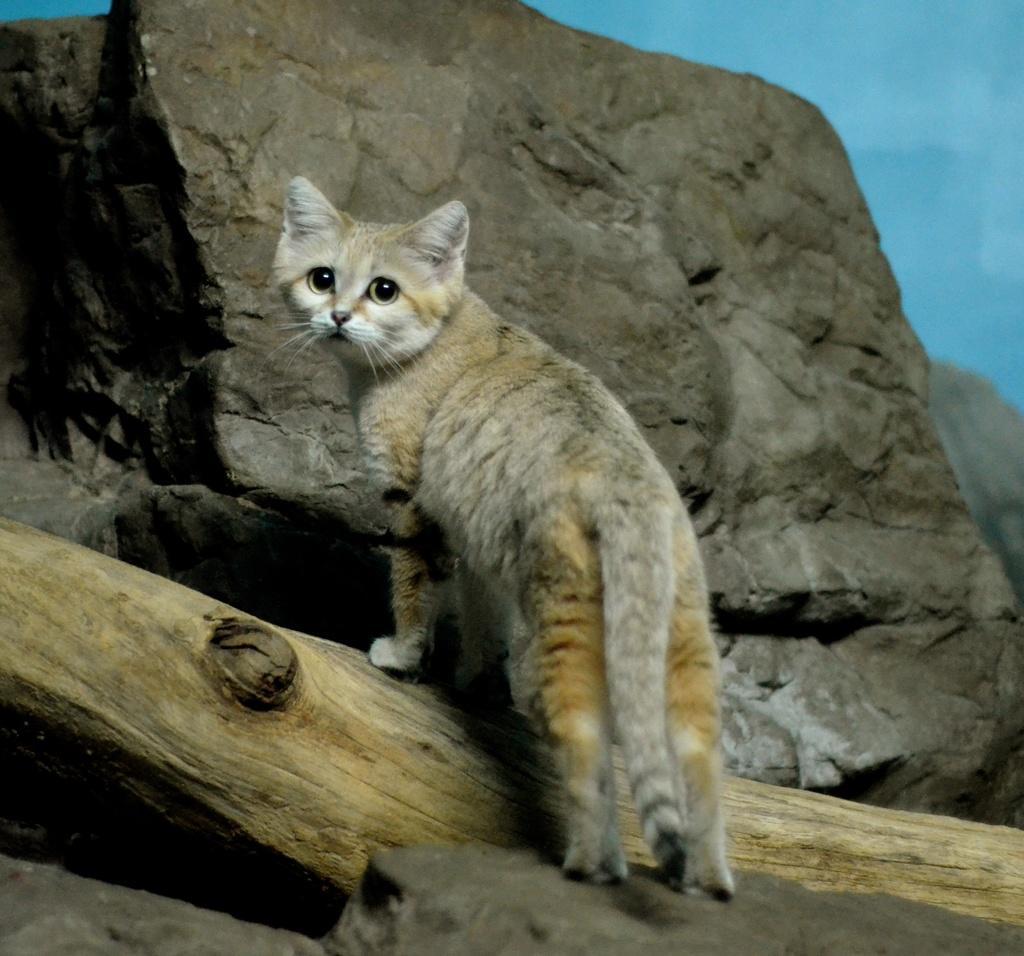Could you give a brief overview of what you see in this image? Here we can see a cat and there is a rock. In the background there is sky. 